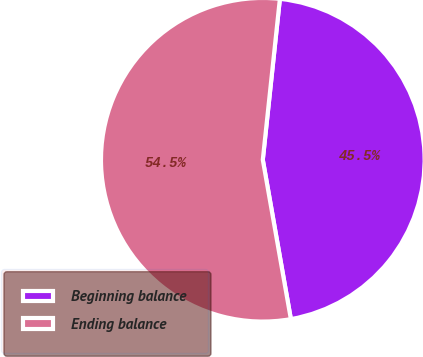<chart> <loc_0><loc_0><loc_500><loc_500><pie_chart><fcel>Beginning balance<fcel>Ending balance<nl><fcel>45.54%<fcel>54.46%<nl></chart> 